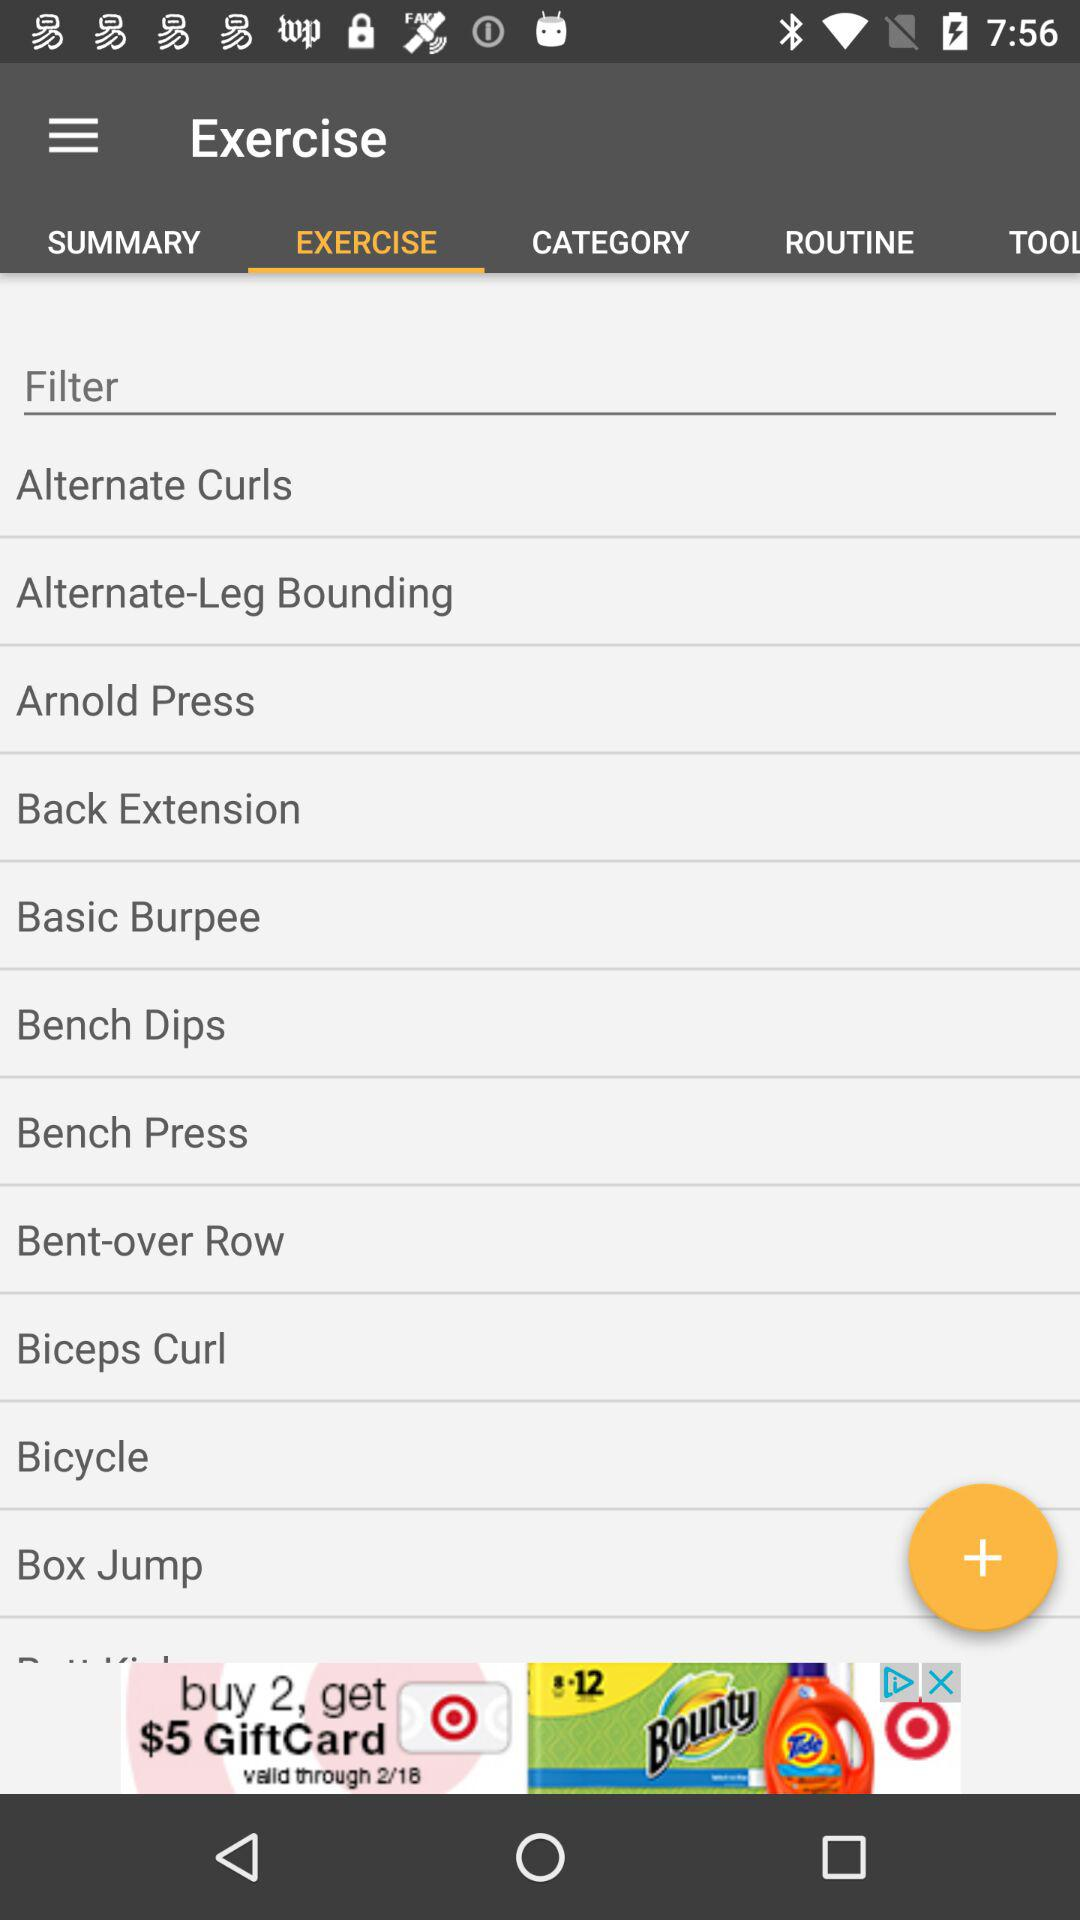Which is the selected tab? The selected tab is "EXERCISE". 